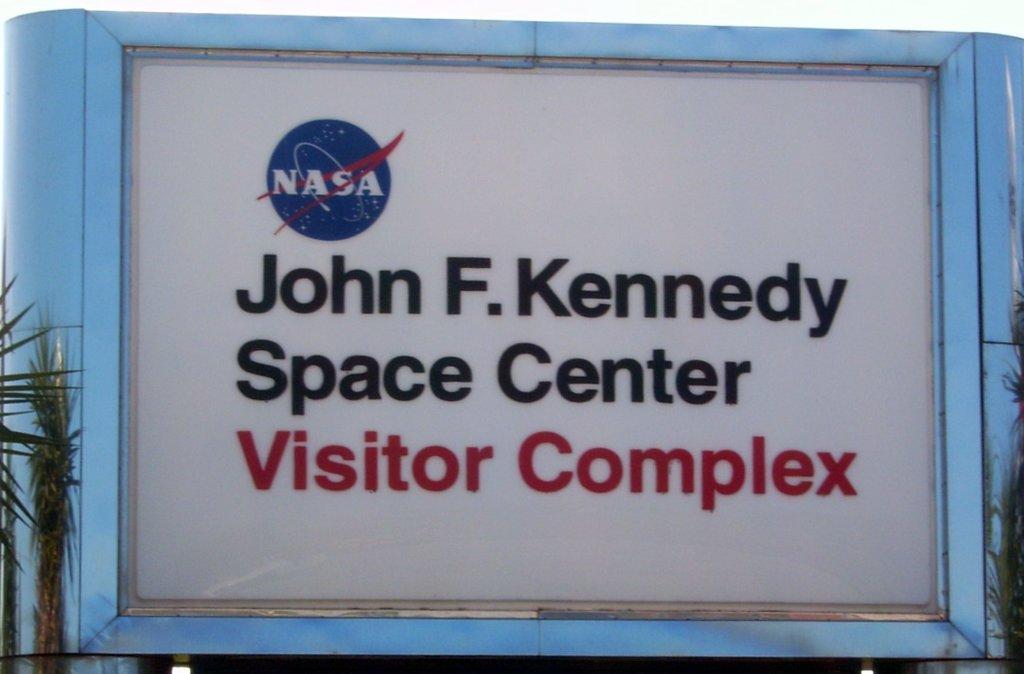What president is listed?
Offer a very short reply. John f. kennedy. Is this the visitor's complex?
Keep it short and to the point. Yes. 